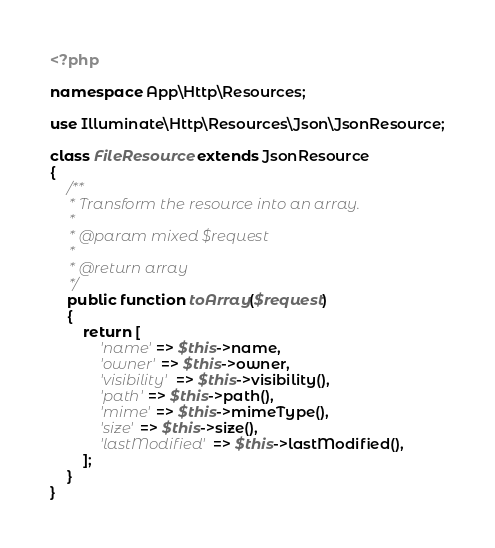Convert code to text. <code><loc_0><loc_0><loc_500><loc_500><_PHP_><?php

namespace App\Http\Resources;

use Illuminate\Http\Resources\Json\JsonResource;

class FileResource extends JsonResource
{
    /**
     * Transform the resource into an array.
     *
     * @param mixed $request
     *
     * @return array
     */
    public function toArray($request)
    {
        return [
            'name' => $this->name,
            'owner' => $this->owner,
            'visibility' => $this->visibility(),
            'path' => $this->path(),
            'mime' => $this->mimeType(),
            'size' => $this->size(),
            'lastModified' => $this->lastModified(),
        ];
    }
}
</code> 